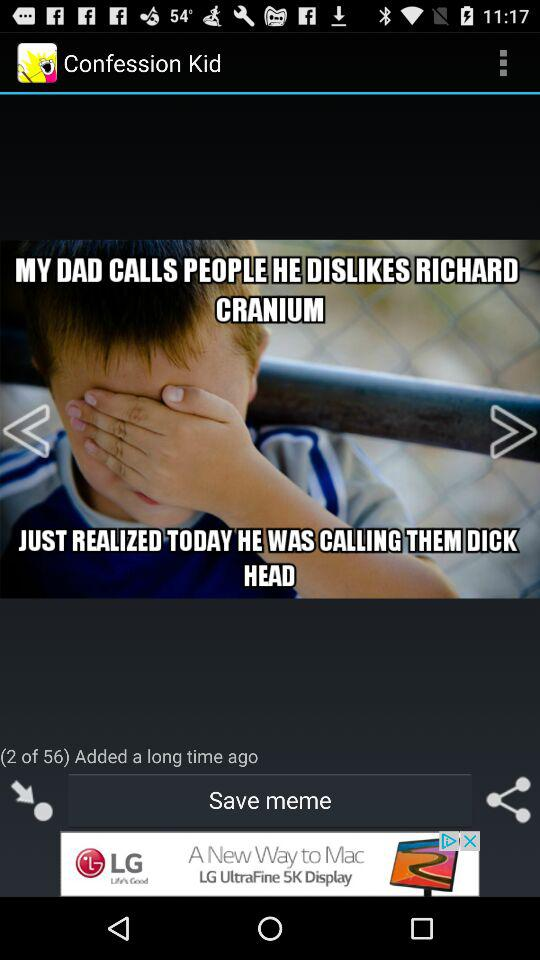What is the name of the application? The name of the application is "GATM Meme Generator". 